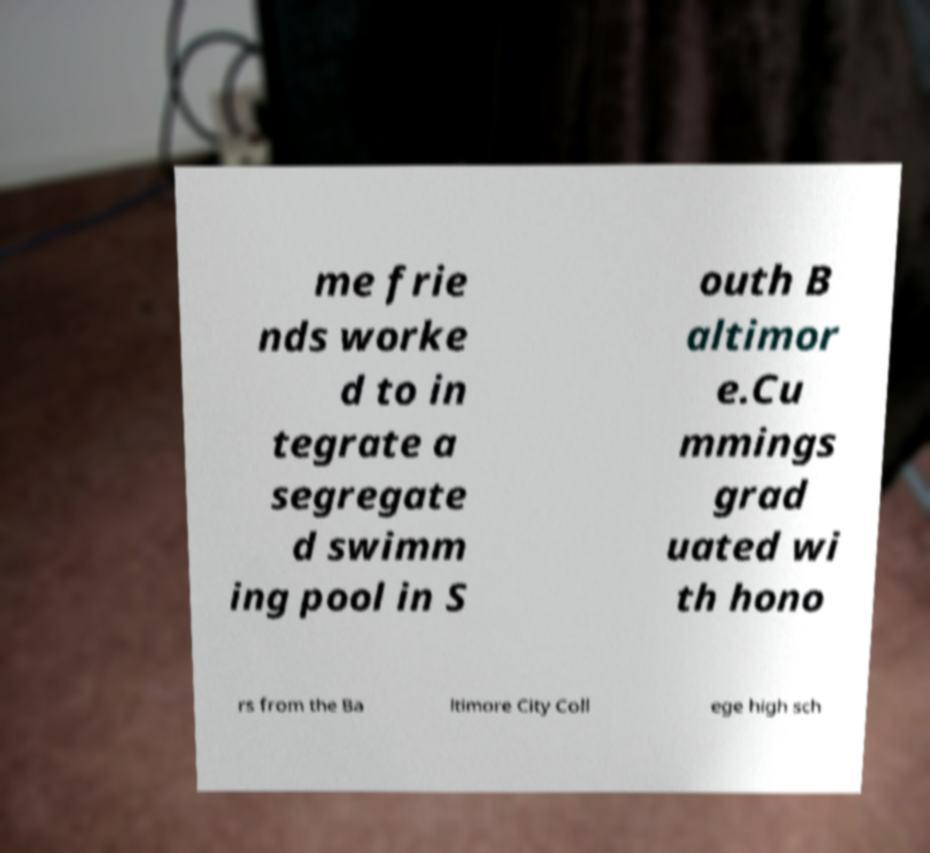What messages or text are displayed in this image? I need them in a readable, typed format. me frie nds worke d to in tegrate a segregate d swimm ing pool in S outh B altimor e.Cu mmings grad uated wi th hono rs from the Ba ltimore City Coll ege high sch 